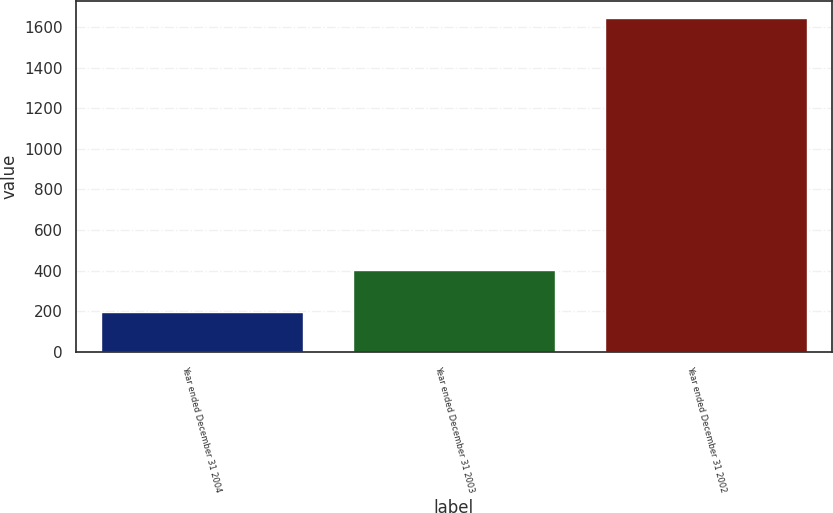<chart> <loc_0><loc_0><loc_500><loc_500><bar_chart><fcel>Year ended December 31 2004<fcel>Year ended December 31 2003<fcel>Year ended December 31 2002<nl><fcel>195<fcel>405<fcel>1648<nl></chart> 